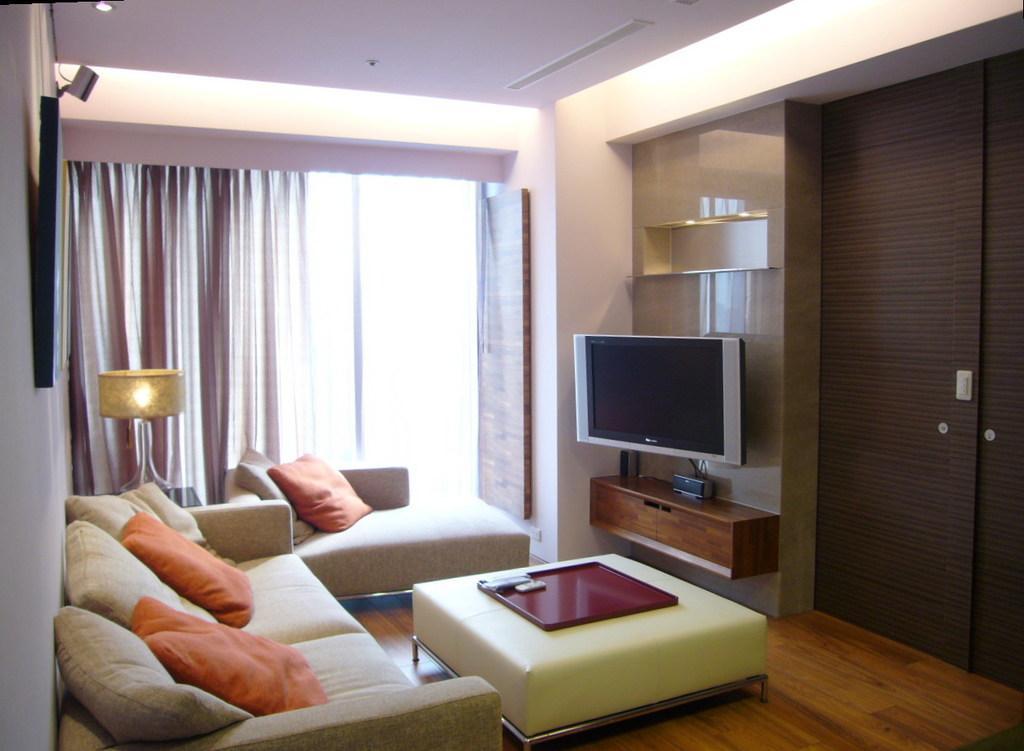In one or two sentences, can you explain what this image depicts? In this picture we can see a room with sofa pillows on it, table with tray on it and in the background we can see window with curtains, lamp, television, racks, door. 